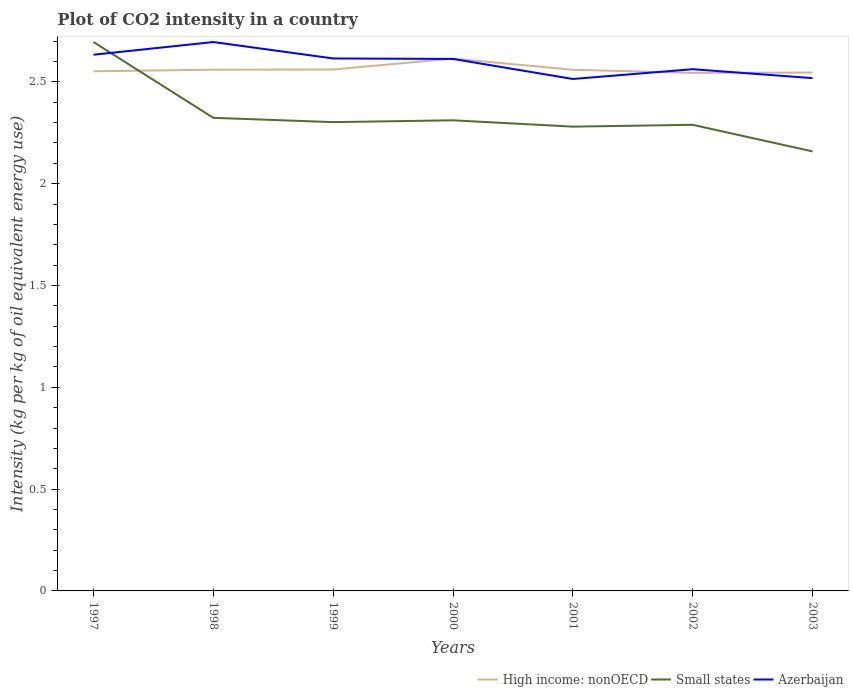Does the line corresponding to High income: nonOECD intersect with the line corresponding to Small states?
Make the answer very short. Yes. Is the number of lines equal to the number of legend labels?
Provide a succinct answer. Yes. Across all years, what is the maximum CO2 intensity in in Azerbaijan?
Ensure brevity in your answer.  2.51. What is the total CO2 intensity in in High income: nonOECD in the graph?
Your answer should be very brief. -0.05. What is the difference between the highest and the second highest CO2 intensity in in Azerbaijan?
Provide a short and direct response. 0.18. What is the difference between the highest and the lowest CO2 intensity in in Small states?
Provide a succinct answer. 1. How many lines are there?
Make the answer very short. 3. How many years are there in the graph?
Your answer should be very brief. 7. What is the difference between two consecutive major ticks on the Y-axis?
Offer a very short reply. 0.5. Are the values on the major ticks of Y-axis written in scientific E-notation?
Provide a succinct answer. No. Does the graph contain any zero values?
Provide a succinct answer. No. Does the graph contain grids?
Offer a terse response. No. What is the title of the graph?
Your answer should be compact. Plot of CO2 intensity in a country. Does "Ecuador" appear as one of the legend labels in the graph?
Your answer should be very brief. No. What is the label or title of the X-axis?
Give a very brief answer. Years. What is the label or title of the Y-axis?
Your answer should be compact. Intensity (kg per kg of oil equivalent energy use). What is the Intensity (kg per kg of oil equivalent energy use) in High income: nonOECD in 1997?
Keep it short and to the point. 2.55. What is the Intensity (kg per kg of oil equivalent energy use) in Small states in 1997?
Offer a very short reply. 2.7. What is the Intensity (kg per kg of oil equivalent energy use) in Azerbaijan in 1997?
Provide a short and direct response. 2.63. What is the Intensity (kg per kg of oil equivalent energy use) of High income: nonOECD in 1998?
Offer a very short reply. 2.56. What is the Intensity (kg per kg of oil equivalent energy use) of Small states in 1998?
Your answer should be compact. 2.32. What is the Intensity (kg per kg of oil equivalent energy use) in Azerbaijan in 1998?
Offer a terse response. 2.7. What is the Intensity (kg per kg of oil equivalent energy use) of High income: nonOECD in 1999?
Provide a succinct answer. 2.56. What is the Intensity (kg per kg of oil equivalent energy use) in Small states in 1999?
Provide a short and direct response. 2.3. What is the Intensity (kg per kg of oil equivalent energy use) in Azerbaijan in 1999?
Offer a terse response. 2.61. What is the Intensity (kg per kg of oil equivalent energy use) in High income: nonOECD in 2000?
Ensure brevity in your answer.  2.61. What is the Intensity (kg per kg of oil equivalent energy use) of Small states in 2000?
Give a very brief answer. 2.31. What is the Intensity (kg per kg of oil equivalent energy use) of Azerbaijan in 2000?
Your answer should be very brief. 2.61. What is the Intensity (kg per kg of oil equivalent energy use) in High income: nonOECD in 2001?
Your response must be concise. 2.56. What is the Intensity (kg per kg of oil equivalent energy use) in Small states in 2001?
Provide a succinct answer. 2.28. What is the Intensity (kg per kg of oil equivalent energy use) of Azerbaijan in 2001?
Offer a terse response. 2.51. What is the Intensity (kg per kg of oil equivalent energy use) of High income: nonOECD in 2002?
Your response must be concise. 2.54. What is the Intensity (kg per kg of oil equivalent energy use) of Small states in 2002?
Give a very brief answer. 2.29. What is the Intensity (kg per kg of oil equivalent energy use) of Azerbaijan in 2002?
Make the answer very short. 2.56. What is the Intensity (kg per kg of oil equivalent energy use) in High income: nonOECD in 2003?
Provide a short and direct response. 2.55. What is the Intensity (kg per kg of oil equivalent energy use) of Small states in 2003?
Make the answer very short. 2.16. What is the Intensity (kg per kg of oil equivalent energy use) of Azerbaijan in 2003?
Provide a succinct answer. 2.52. Across all years, what is the maximum Intensity (kg per kg of oil equivalent energy use) in High income: nonOECD?
Ensure brevity in your answer.  2.61. Across all years, what is the maximum Intensity (kg per kg of oil equivalent energy use) of Small states?
Your answer should be compact. 2.7. Across all years, what is the maximum Intensity (kg per kg of oil equivalent energy use) in Azerbaijan?
Ensure brevity in your answer.  2.7. Across all years, what is the minimum Intensity (kg per kg of oil equivalent energy use) in High income: nonOECD?
Make the answer very short. 2.54. Across all years, what is the minimum Intensity (kg per kg of oil equivalent energy use) of Small states?
Make the answer very short. 2.16. Across all years, what is the minimum Intensity (kg per kg of oil equivalent energy use) of Azerbaijan?
Provide a short and direct response. 2.51. What is the total Intensity (kg per kg of oil equivalent energy use) in High income: nonOECD in the graph?
Your response must be concise. 17.93. What is the total Intensity (kg per kg of oil equivalent energy use) of Small states in the graph?
Provide a succinct answer. 16.36. What is the total Intensity (kg per kg of oil equivalent energy use) of Azerbaijan in the graph?
Your answer should be very brief. 18.15. What is the difference between the Intensity (kg per kg of oil equivalent energy use) in High income: nonOECD in 1997 and that in 1998?
Your answer should be compact. -0.01. What is the difference between the Intensity (kg per kg of oil equivalent energy use) in Small states in 1997 and that in 1998?
Make the answer very short. 0.37. What is the difference between the Intensity (kg per kg of oil equivalent energy use) in Azerbaijan in 1997 and that in 1998?
Offer a terse response. -0.06. What is the difference between the Intensity (kg per kg of oil equivalent energy use) of High income: nonOECD in 1997 and that in 1999?
Ensure brevity in your answer.  -0.01. What is the difference between the Intensity (kg per kg of oil equivalent energy use) in Small states in 1997 and that in 1999?
Keep it short and to the point. 0.39. What is the difference between the Intensity (kg per kg of oil equivalent energy use) of Azerbaijan in 1997 and that in 1999?
Provide a short and direct response. 0.02. What is the difference between the Intensity (kg per kg of oil equivalent energy use) of High income: nonOECD in 1997 and that in 2000?
Give a very brief answer. -0.06. What is the difference between the Intensity (kg per kg of oil equivalent energy use) of Small states in 1997 and that in 2000?
Offer a terse response. 0.38. What is the difference between the Intensity (kg per kg of oil equivalent energy use) in Azerbaijan in 1997 and that in 2000?
Provide a short and direct response. 0.02. What is the difference between the Intensity (kg per kg of oil equivalent energy use) in High income: nonOECD in 1997 and that in 2001?
Your answer should be very brief. -0.01. What is the difference between the Intensity (kg per kg of oil equivalent energy use) of Small states in 1997 and that in 2001?
Give a very brief answer. 0.42. What is the difference between the Intensity (kg per kg of oil equivalent energy use) in Azerbaijan in 1997 and that in 2001?
Provide a succinct answer. 0.12. What is the difference between the Intensity (kg per kg of oil equivalent energy use) in High income: nonOECD in 1997 and that in 2002?
Provide a short and direct response. 0.01. What is the difference between the Intensity (kg per kg of oil equivalent energy use) of Small states in 1997 and that in 2002?
Your answer should be compact. 0.41. What is the difference between the Intensity (kg per kg of oil equivalent energy use) of Azerbaijan in 1997 and that in 2002?
Provide a short and direct response. 0.07. What is the difference between the Intensity (kg per kg of oil equivalent energy use) in High income: nonOECD in 1997 and that in 2003?
Provide a succinct answer. 0.01. What is the difference between the Intensity (kg per kg of oil equivalent energy use) in Small states in 1997 and that in 2003?
Provide a short and direct response. 0.54. What is the difference between the Intensity (kg per kg of oil equivalent energy use) of Azerbaijan in 1997 and that in 2003?
Your response must be concise. 0.12. What is the difference between the Intensity (kg per kg of oil equivalent energy use) of High income: nonOECD in 1998 and that in 1999?
Ensure brevity in your answer.  -0. What is the difference between the Intensity (kg per kg of oil equivalent energy use) of Small states in 1998 and that in 1999?
Keep it short and to the point. 0.02. What is the difference between the Intensity (kg per kg of oil equivalent energy use) of Azerbaijan in 1998 and that in 1999?
Provide a succinct answer. 0.08. What is the difference between the Intensity (kg per kg of oil equivalent energy use) in High income: nonOECD in 1998 and that in 2000?
Your response must be concise. -0.05. What is the difference between the Intensity (kg per kg of oil equivalent energy use) in Small states in 1998 and that in 2000?
Your answer should be compact. 0.01. What is the difference between the Intensity (kg per kg of oil equivalent energy use) in Azerbaijan in 1998 and that in 2000?
Provide a short and direct response. 0.08. What is the difference between the Intensity (kg per kg of oil equivalent energy use) of Small states in 1998 and that in 2001?
Your answer should be very brief. 0.04. What is the difference between the Intensity (kg per kg of oil equivalent energy use) in Azerbaijan in 1998 and that in 2001?
Offer a terse response. 0.18. What is the difference between the Intensity (kg per kg of oil equivalent energy use) of High income: nonOECD in 1998 and that in 2002?
Offer a very short reply. 0.02. What is the difference between the Intensity (kg per kg of oil equivalent energy use) of Small states in 1998 and that in 2002?
Your answer should be compact. 0.03. What is the difference between the Intensity (kg per kg of oil equivalent energy use) in Azerbaijan in 1998 and that in 2002?
Provide a succinct answer. 0.13. What is the difference between the Intensity (kg per kg of oil equivalent energy use) in High income: nonOECD in 1998 and that in 2003?
Your answer should be very brief. 0.01. What is the difference between the Intensity (kg per kg of oil equivalent energy use) in Small states in 1998 and that in 2003?
Offer a very short reply. 0.16. What is the difference between the Intensity (kg per kg of oil equivalent energy use) in Azerbaijan in 1998 and that in 2003?
Offer a very short reply. 0.18. What is the difference between the Intensity (kg per kg of oil equivalent energy use) of High income: nonOECD in 1999 and that in 2000?
Make the answer very short. -0.05. What is the difference between the Intensity (kg per kg of oil equivalent energy use) of Small states in 1999 and that in 2000?
Provide a short and direct response. -0.01. What is the difference between the Intensity (kg per kg of oil equivalent energy use) in Azerbaijan in 1999 and that in 2000?
Give a very brief answer. 0. What is the difference between the Intensity (kg per kg of oil equivalent energy use) of High income: nonOECD in 1999 and that in 2001?
Give a very brief answer. 0. What is the difference between the Intensity (kg per kg of oil equivalent energy use) in Small states in 1999 and that in 2001?
Provide a succinct answer. 0.02. What is the difference between the Intensity (kg per kg of oil equivalent energy use) of Azerbaijan in 1999 and that in 2001?
Your answer should be very brief. 0.1. What is the difference between the Intensity (kg per kg of oil equivalent energy use) in High income: nonOECD in 1999 and that in 2002?
Your answer should be compact. 0.02. What is the difference between the Intensity (kg per kg of oil equivalent energy use) of Small states in 1999 and that in 2002?
Your answer should be compact. 0.01. What is the difference between the Intensity (kg per kg of oil equivalent energy use) in Azerbaijan in 1999 and that in 2002?
Provide a succinct answer. 0.05. What is the difference between the Intensity (kg per kg of oil equivalent energy use) in High income: nonOECD in 1999 and that in 2003?
Your answer should be compact. 0.02. What is the difference between the Intensity (kg per kg of oil equivalent energy use) in Small states in 1999 and that in 2003?
Your answer should be compact. 0.14. What is the difference between the Intensity (kg per kg of oil equivalent energy use) of Azerbaijan in 1999 and that in 2003?
Offer a very short reply. 0.1. What is the difference between the Intensity (kg per kg of oil equivalent energy use) in High income: nonOECD in 2000 and that in 2001?
Ensure brevity in your answer.  0.05. What is the difference between the Intensity (kg per kg of oil equivalent energy use) in Small states in 2000 and that in 2001?
Offer a very short reply. 0.03. What is the difference between the Intensity (kg per kg of oil equivalent energy use) in Azerbaijan in 2000 and that in 2001?
Your answer should be compact. 0.1. What is the difference between the Intensity (kg per kg of oil equivalent energy use) in High income: nonOECD in 2000 and that in 2002?
Ensure brevity in your answer.  0.07. What is the difference between the Intensity (kg per kg of oil equivalent energy use) of Small states in 2000 and that in 2002?
Provide a short and direct response. 0.02. What is the difference between the Intensity (kg per kg of oil equivalent energy use) of Azerbaijan in 2000 and that in 2002?
Provide a short and direct response. 0.05. What is the difference between the Intensity (kg per kg of oil equivalent energy use) of High income: nonOECD in 2000 and that in 2003?
Provide a short and direct response. 0.07. What is the difference between the Intensity (kg per kg of oil equivalent energy use) in Small states in 2000 and that in 2003?
Ensure brevity in your answer.  0.15. What is the difference between the Intensity (kg per kg of oil equivalent energy use) of Azerbaijan in 2000 and that in 2003?
Your response must be concise. 0.09. What is the difference between the Intensity (kg per kg of oil equivalent energy use) in High income: nonOECD in 2001 and that in 2002?
Ensure brevity in your answer.  0.02. What is the difference between the Intensity (kg per kg of oil equivalent energy use) in Small states in 2001 and that in 2002?
Offer a very short reply. -0.01. What is the difference between the Intensity (kg per kg of oil equivalent energy use) in Azerbaijan in 2001 and that in 2002?
Provide a succinct answer. -0.05. What is the difference between the Intensity (kg per kg of oil equivalent energy use) of High income: nonOECD in 2001 and that in 2003?
Provide a succinct answer. 0.01. What is the difference between the Intensity (kg per kg of oil equivalent energy use) in Small states in 2001 and that in 2003?
Provide a short and direct response. 0.12. What is the difference between the Intensity (kg per kg of oil equivalent energy use) in Azerbaijan in 2001 and that in 2003?
Provide a short and direct response. -0. What is the difference between the Intensity (kg per kg of oil equivalent energy use) of High income: nonOECD in 2002 and that in 2003?
Provide a succinct answer. -0. What is the difference between the Intensity (kg per kg of oil equivalent energy use) in Small states in 2002 and that in 2003?
Offer a terse response. 0.13. What is the difference between the Intensity (kg per kg of oil equivalent energy use) of Azerbaijan in 2002 and that in 2003?
Offer a terse response. 0.04. What is the difference between the Intensity (kg per kg of oil equivalent energy use) in High income: nonOECD in 1997 and the Intensity (kg per kg of oil equivalent energy use) in Small states in 1998?
Provide a short and direct response. 0.23. What is the difference between the Intensity (kg per kg of oil equivalent energy use) of High income: nonOECD in 1997 and the Intensity (kg per kg of oil equivalent energy use) of Azerbaijan in 1998?
Offer a terse response. -0.14. What is the difference between the Intensity (kg per kg of oil equivalent energy use) of Small states in 1997 and the Intensity (kg per kg of oil equivalent energy use) of Azerbaijan in 1998?
Your response must be concise. -0. What is the difference between the Intensity (kg per kg of oil equivalent energy use) of High income: nonOECD in 1997 and the Intensity (kg per kg of oil equivalent energy use) of Small states in 1999?
Offer a terse response. 0.25. What is the difference between the Intensity (kg per kg of oil equivalent energy use) of High income: nonOECD in 1997 and the Intensity (kg per kg of oil equivalent energy use) of Azerbaijan in 1999?
Provide a succinct answer. -0.06. What is the difference between the Intensity (kg per kg of oil equivalent energy use) in Small states in 1997 and the Intensity (kg per kg of oil equivalent energy use) in Azerbaijan in 1999?
Provide a succinct answer. 0.08. What is the difference between the Intensity (kg per kg of oil equivalent energy use) of High income: nonOECD in 1997 and the Intensity (kg per kg of oil equivalent energy use) of Small states in 2000?
Offer a terse response. 0.24. What is the difference between the Intensity (kg per kg of oil equivalent energy use) of High income: nonOECD in 1997 and the Intensity (kg per kg of oil equivalent energy use) of Azerbaijan in 2000?
Provide a succinct answer. -0.06. What is the difference between the Intensity (kg per kg of oil equivalent energy use) in Small states in 1997 and the Intensity (kg per kg of oil equivalent energy use) in Azerbaijan in 2000?
Make the answer very short. 0.08. What is the difference between the Intensity (kg per kg of oil equivalent energy use) of High income: nonOECD in 1997 and the Intensity (kg per kg of oil equivalent energy use) of Small states in 2001?
Offer a very short reply. 0.27. What is the difference between the Intensity (kg per kg of oil equivalent energy use) of High income: nonOECD in 1997 and the Intensity (kg per kg of oil equivalent energy use) of Azerbaijan in 2001?
Your answer should be compact. 0.04. What is the difference between the Intensity (kg per kg of oil equivalent energy use) of Small states in 1997 and the Intensity (kg per kg of oil equivalent energy use) of Azerbaijan in 2001?
Give a very brief answer. 0.18. What is the difference between the Intensity (kg per kg of oil equivalent energy use) in High income: nonOECD in 1997 and the Intensity (kg per kg of oil equivalent energy use) in Small states in 2002?
Give a very brief answer. 0.26. What is the difference between the Intensity (kg per kg of oil equivalent energy use) of High income: nonOECD in 1997 and the Intensity (kg per kg of oil equivalent energy use) of Azerbaijan in 2002?
Your answer should be compact. -0.01. What is the difference between the Intensity (kg per kg of oil equivalent energy use) in Small states in 1997 and the Intensity (kg per kg of oil equivalent energy use) in Azerbaijan in 2002?
Provide a succinct answer. 0.13. What is the difference between the Intensity (kg per kg of oil equivalent energy use) of High income: nonOECD in 1997 and the Intensity (kg per kg of oil equivalent energy use) of Small states in 2003?
Offer a very short reply. 0.39. What is the difference between the Intensity (kg per kg of oil equivalent energy use) in High income: nonOECD in 1997 and the Intensity (kg per kg of oil equivalent energy use) in Azerbaijan in 2003?
Offer a terse response. 0.03. What is the difference between the Intensity (kg per kg of oil equivalent energy use) in Small states in 1997 and the Intensity (kg per kg of oil equivalent energy use) in Azerbaijan in 2003?
Keep it short and to the point. 0.18. What is the difference between the Intensity (kg per kg of oil equivalent energy use) of High income: nonOECD in 1998 and the Intensity (kg per kg of oil equivalent energy use) of Small states in 1999?
Make the answer very short. 0.26. What is the difference between the Intensity (kg per kg of oil equivalent energy use) in High income: nonOECD in 1998 and the Intensity (kg per kg of oil equivalent energy use) in Azerbaijan in 1999?
Provide a short and direct response. -0.06. What is the difference between the Intensity (kg per kg of oil equivalent energy use) in Small states in 1998 and the Intensity (kg per kg of oil equivalent energy use) in Azerbaijan in 1999?
Ensure brevity in your answer.  -0.29. What is the difference between the Intensity (kg per kg of oil equivalent energy use) in High income: nonOECD in 1998 and the Intensity (kg per kg of oil equivalent energy use) in Small states in 2000?
Give a very brief answer. 0.25. What is the difference between the Intensity (kg per kg of oil equivalent energy use) in High income: nonOECD in 1998 and the Intensity (kg per kg of oil equivalent energy use) in Azerbaijan in 2000?
Ensure brevity in your answer.  -0.05. What is the difference between the Intensity (kg per kg of oil equivalent energy use) of Small states in 1998 and the Intensity (kg per kg of oil equivalent energy use) of Azerbaijan in 2000?
Make the answer very short. -0.29. What is the difference between the Intensity (kg per kg of oil equivalent energy use) in High income: nonOECD in 1998 and the Intensity (kg per kg of oil equivalent energy use) in Small states in 2001?
Make the answer very short. 0.28. What is the difference between the Intensity (kg per kg of oil equivalent energy use) of High income: nonOECD in 1998 and the Intensity (kg per kg of oil equivalent energy use) of Azerbaijan in 2001?
Provide a succinct answer. 0.05. What is the difference between the Intensity (kg per kg of oil equivalent energy use) in Small states in 1998 and the Intensity (kg per kg of oil equivalent energy use) in Azerbaijan in 2001?
Make the answer very short. -0.19. What is the difference between the Intensity (kg per kg of oil equivalent energy use) in High income: nonOECD in 1998 and the Intensity (kg per kg of oil equivalent energy use) in Small states in 2002?
Keep it short and to the point. 0.27. What is the difference between the Intensity (kg per kg of oil equivalent energy use) of High income: nonOECD in 1998 and the Intensity (kg per kg of oil equivalent energy use) of Azerbaijan in 2002?
Ensure brevity in your answer.  -0. What is the difference between the Intensity (kg per kg of oil equivalent energy use) of Small states in 1998 and the Intensity (kg per kg of oil equivalent energy use) of Azerbaijan in 2002?
Offer a terse response. -0.24. What is the difference between the Intensity (kg per kg of oil equivalent energy use) of High income: nonOECD in 1998 and the Intensity (kg per kg of oil equivalent energy use) of Small states in 2003?
Provide a succinct answer. 0.4. What is the difference between the Intensity (kg per kg of oil equivalent energy use) in High income: nonOECD in 1998 and the Intensity (kg per kg of oil equivalent energy use) in Azerbaijan in 2003?
Make the answer very short. 0.04. What is the difference between the Intensity (kg per kg of oil equivalent energy use) in Small states in 1998 and the Intensity (kg per kg of oil equivalent energy use) in Azerbaijan in 2003?
Provide a succinct answer. -0.19. What is the difference between the Intensity (kg per kg of oil equivalent energy use) in High income: nonOECD in 1999 and the Intensity (kg per kg of oil equivalent energy use) in Small states in 2000?
Keep it short and to the point. 0.25. What is the difference between the Intensity (kg per kg of oil equivalent energy use) of High income: nonOECD in 1999 and the Intensity (kg per kg of oil equivalent energy use) of Azerbaijan in 2000?
Provide a succinct answer. -0.05. What is the difference between the Intensity (kg per kg of oil equivalent energy use) of Small states in 1999 and the Intensity (kg per kg of oil equivalent energy use) of Azerbaijan in 2000?
Your answer should be very brief. -0.31. What is the difference between the Intensity (kg per kg of oil equivalent energy use) of High income: nonOECD in 1999 and the Intensity (kg per kg of oil equivalent energy use) of Small states in 2001?
Give a very brief answer. 0.28. What is the difference between the Intensity (kg per kg of oil equivalent energy use) in High income: nonOECD in 1999 and the Intensity (kg per kg of oil equivalent energy use) in Azerbaijan in 2001?
Your answer should be very brief. 0.05. What is the difference between the Intensity (kg per kg of oil equivalent energy use) of Small states in 1999 and the Intensity (kg per kg of oil equivalent energy use) of Azerbaijan in 2001?
Your response must be concise. -0.21. What is the difference between the Intensity (kg per kg of oil equivalent energy use) in High income: nonOECD in 1999 and the Intensity (kg per kg of oil equivalent energy use) in Small states in 2002?
Your response must be concise. 0.27. What is the difference between the Intensity (kg per kg of oil equivalent energy use) of High income: nonOECD in 1999 and the Intensity (kg per kg of oil equivalent energy use) of Azerbaijan in 2002?
Offer a very short reply. -0. What is the difference between the Intensity (kg per kg of oil equivalent energy use) in Small states in 1999 and the Intensity (kg per kg of oil equivalent energy use) in Azerbaijan in 2002?
Your answer should be very brief. -0.26. What is the difference between the Intensity (kg per kg of oil equivalent energy use) of High income: nonOECD in 1999 and the Intensity (kg per kg of oil equivalent energy use) of Small states in 2003?
Offer a very short reply. 0.4. What is the difference between the Intensity (kg per kg of oil equivalent energy use) in High income: nonOECD in 1999 and the Intensity (kg per kg of oil equivalent energy use) in Azerbaijan in 2003?
Offer a terse response. 0.04. What is the difference between the Intensity (kg per kg of oil equivalent energy use) of Small states in 1999 and the Intensity (kg per kg of oil equivalent energy use) of Azerbaijan in 2003?
Your response must be concise. -0.22. What is the difference between the Intensity (kg per kg of oil equivalent energy use) of High income: nonOECD in 2000 and the Intensity (kg per kg of oil equivalent energy use) of Small states in 2001?
Offer a very short reply. 0.33. What is the difference between the Intensity (kg per kg of oil equivalent energy use) in High income: nonOECD in 2000 and the Intensity (kg per kg of oil equivalent energy use) in Azerbaijan in 2001?
Your answer should be compact. 0.1. What is the difference between the Intensity (kg per kg of oil equivalent energy use) in Small states in 2000 and the Intensity (kg per kg of oil equivalent energy use) in Azerbaijan in 2001?
Your response must be concise. -0.2. What is the difference between the Intensity (kg per kg of oil equivalent energy use) in High income: nonOECD in 2000 and the Intensity (kg per kg of oil equivalent energy use) in Small states in 2002?
Your answer should be very brief. 0.33. What is the difference between the Intensity (kg per kg of oil equivalent energy use) of High income: nonOECD in 2000 and the Intensity (kg per kg of oil equivalent energy use) of Azerbaijan in 2002?
Your answer should be compact. 0.05. What is the difference between the Intensity (kg per kg of oil equivalent energy use) in Small states in 2000 and the Intensity (kg per kg of oil equivalent energy use) in Azerbaijan in 2002?
Give a very brief answer. -0.25. What is the difference between the Intensity (kg per kg of oil equivalent energy use) in High income: nonOECD in 2000 and the Intensity (kg per kg of oil equivalent energy use) in Small states in 2003?
Your response must be concise. 0.46. What is the difference between the Intensity (kg per kg of oil equivalent energy use) in High income: nonOECD in 2000 and the Intensity (kg per kg of oil equivalent energy use) in Azerbaijan in 2003?
Keep it short and to the point. 0.1. What is the difference between the Intensity (kg per kg of oil equivalent energy use) of Small states in 2000 and the Intensity (kg per kg of oil equivalent energy use) of Azerbaijan in 2003?
Offer a terse response. -0.21. What is the difference between the Intensity (kg per kg of oil equivalent energy use) in High income: nonOECD in 2001 and the Intensity (kg per kg of oil equivalent energy use) in Small states in 2002?
Provide a succinct answer. 0.27. What is the difference between the Intensity (kg per kg of oil equivalent energy use) in High income: nonOECD in 2001 and the Intensity (kg per kg of oil equivalent energy use) in Azerbaijan in 2002?
Ensure brevity in your answer.  -0. What is the difference between the Intensity (kg per kg of oil equivalent energy use) of Small states in 2001 and the Intensity (kg per kg of oil equivalent energy use) of Azerbaijan in 2002?
Your answer should be compact. -0.28. What is the difference between the Intensity (kg per kg of oil equivalent energy use) in High income: nonOECD in 2001 and the Intensity (kg per kg of oil equivalent energy use) in Small states in 2003?
Provide a short and direct response. 0.4. What is the difference between the Intensity (kg per kg of oil equivalent energy use) of High income: nonOECD in 2001 and the Intensity (kg per kg of oil equivalent energy use) of Azerbaijan in 2003?
Your answer should be compact. 0.04. What is the difference between the Intensity (kg per kg of oil equivalent energy use) in Small states in 2001 and the Intensity (kg per kg of oil equivalent energy use) in Azerbaijan in 2003?
Your answer should be very brief. -0.24. What is the difference between the Intensity (kg per kg of oil equivalent energy use) of High income: nonOECD in 2002 and the Intensity (kg per kg of oil equivalent energy use) of Small states in 2003?
Provide a succinct answer. 0.39. What is the difference between the Intensity (kg per kg of oil equivalent energy use) in High income: nonOECD in 2002 and the Intensity (kg per kg of oil equivalent energy use) in Azerbaijan in 2003?
Make the answer very short. 0.03. What is the difference between the Intensity (kg per kg of oil equivalent energy use) in Small states in 2002 and the Intensity (kg per kg of oil equivalent energy use) in Azerbaijan in 2003?
Offer a very short reply. -0.23. What is the average Intensity (kg per kg of oil equivalent energy use) in High income: nonOECD per year?
Make the answer very short. 2.56. What is the average Intensity (kg per kg of oil equivalent energy use) in Small states per year?
Provide a succinct answer. 2.34. What is the average Intensity (kg per kg of oil equivalent energy use) in Azerbaijan per year?
Keep it short and to the point. 2.59. In the year 1997, what is the difference between the Intensity (kg per kg of oil equivalent energy use) of High income: nonOECD and Intensity (kg per kg of oil equivalent energy use) of Small states?
Ensure brevity in your answer.  -0.14. In the year 1997, what is the difference between the Intensity (kg per kg of oil equivalent energy use) of High income: nonOECD and Intensity (kg per kg of oil equivalent energy use) of Azerbaijan?
Your answer should be very brief. -0.08. In the year 1997, what is the difference between the Intensity (kg per kg of oil equivalent energy use) in Small states and Intensity (kg per kg of oil equivalent energy use) in Azerbaijan?
Provide a short and direct response. 0.06. In the year 1998, what is the difference between the Intensity (kg per kg of oil equivalent energy use) of High income: nonOECD and Intensity (kg per kg of oil equivalent energy use) of Small states?
Ensure brevity in your answer.  0.24. In the year 1998, what is the difference between the Intensity (kg per kg of oil equivalent energy use) in High income: nonOECD and Intensity (kg per kg of oil equivalent energy use) in Azerbaijan?
Offer a very short reply. -0.14. In the year 1998, what is the difference between the Intensity (kg per kg of oil equivalent energy use) in Small states and Intensity (kg per kg of oil equivalent energy use) in Azerbaijan?
Keep it short and to the point. -0.37. In the year 1999, what is the difference between the Intensity (kg per kg of oil equivalent energy use) of High income: nonOECD and Intensity (kg per kg of oil equivalent energy use) of Small states?
Provide a succinct answer. 0.26. In the year 1999, what is the difference between the Intensity (kg per kg of oil equivalent energy use) of High income: nonOECD and Intensity (kg per kg of oil equivalent energy use) of Azerbaijan?
Ensure brevity in your answer.  -0.05. In the year 1999, what is the difference between the Intensity (kg per kg of oil equivalent energy use) in Small states and Intensity (kg per kg of oil equivalent energy use) in Azerbaijan?
Your answer should be very brief. -0.31. In the year 2000, what is the difference between the Intensity (kg per kg of oil equivalent energy use) of High income: nonOECD and Intensity (kg per kg of oil equivalent energy use) of Small states?
Your response must be concise. 0.3. In the year 2000, what is the difference between the Intensity (kg per kg of oil equivalent energy use) of High income: nonOECD and Intensity (kg per kg of oil equivalent energy use) of Azerbaijan?
Your response must be concise. 0. In the year 2000, what is the difference between the Intensity (kg per kg of oil equivalent energy use) of Small states and Intensity (kg per kg of oil equivalent energy use) of Azerbaijan?
Your answer should be compact. -0.3. In the year 2001, what is the difference between the Intensity (kg per kg of oil equivalent energy use) of High income: nonOECD and Intensity (kg per kg of oil equivalent energy use) of Small states?
Keep it short and to the point. 0.28. In the year 2001, what is the difference between the Intensity (kg per kg of oil equivalent energy use) in High income: nonOECD and Intensity (kg per kg of oil equivalent energy use) in Azerbaijan?
Your response must be concise. 0.05. In the year 2001, what is the difference between the Intensity (kg per kg of oil equivalent energy use) of Small states and Intensity (kg per kg of oil equivalent energy use) of Azerbaijan?
Offer a very short reply. -0.23. In the year 2002, what is the difference between the Intensity (kg per kg of oil equivalent energy use) of High income: nonOECD and Intensity (kg per kg of oil equivalent energy use) of Small states?
Offer a terse response. 0.26. In the year 2002, what is the difference between the Intensity (kg per kg of oil equivalent energy use) in High income: nonOECD and Intensity (kg per kg of oil equivalent energy use) in Azerbaijan?
Offer a terse response. -0.02. In the year 2002, what is the difference between the Intensity (kg per kg of oil equivalent energy use) of Small states and Intensity (kg per kg of oil equivalent energy use) of Azerbaijan?
Provide a short and direct response. -0.27. In the year 2003, what is the difference between the Intensity (kg per kg of oil equivalent energy use) of High income: nonOECD and Intensity (kg per kg of oil equivalent energy use) of Small states?
Provide a short and direct response. 0.39. In the year 2003, what is the difference between the Intensity (kg per kg of oil equivalent energy use) in High income: nonOECD and Intensity (kg per kg of oil equivalent energy use) in Azerbaijan?
Make the answer very short. 0.03. In the year 2003, what is the difference between the Intensity (kg per kg of oil equivalent energy use) of Small states and Intensity (kg per kg of oil equivalent energy use) of Azerbaijan?
Your response must be concise. -0.36. What is the ratio of the Intensity (kg per kg of oil equivalent energy use) in High income: nonOECD in 1997 to that in 1998?
Your answer should be very brief. 1. What is the ratio of the Intensity (kg per kg of oil equivalent energy use) of Small states in 1997 to that in 1998?
Provide a short and direct response. 1.16. What is the ratio of the Intensity (kg per kg of oil equivalent energy use) in Azerbaijan in 1997 to that in 1998?
Make the answer very short. 0.98. What is the ratio of the Intensity (kg per kg of oil equivalent energy use) of High income: nonOECD in 1997 to that in 1999?
Ensure brevity in your answer.  1. What is the ratio of the Intensity (kg per kg of oil equivalent energy use) in Small states in 1997 to that in 1999?
Your answer should be very brief. 1.17. What is the ratio of the Intensity (kg per kg of oil equivalent energy use) in High income: nonOECD in 1997 to that in 2000?
Ensure brevity in your answer.  0.98. What is the ratio of the Intensity (kg per kg of oil equivalent energy use) in Small states in 1997 to that in 2000?
Provide a short and direct response. 1.17. What is the ratio of the Intensity (kg per kg of oil equivalent energy use) of Azerbaijan in 1997 to that in 2000?
Provide a short and direct response. 1.01. What is the ratio of the Intensity (kg per kg of oil equivalent energy use) in Small states in 1997 to that in 2001?
Your response must be concise. 1.18. What is the ratio of the Intensity (kg per kg of oil equivalent energy use) in Azerbaijan in 1997 to that in 2001?
Offer a terse response. 1.05. What is the ratio of the Intensity (kg per kg of oil equivalent energy use) of Small states in 1997 to that in 2002?
Make the answer very short. 1.18. What is the ratio of the Intensity (kg per kg of oil equivalent energy use) in Azerbaijan in 1997 to that in 2002?
Offer a terse response. 1.03. What is the ratio of the Intensity (kg per kg of oil equivalent energy use) of Small states in 1997 to that in 2003?
Provide a succinct answer. 1.25. What is the ratio of the Intensity (kg per kg of oil equivalent energy use) of Azerbaijan in 1997 to that in 2003?
Your answer should be very brief. 1.05. What is the ratio of the Intensity (kg per kg of oil equivalent energy use) of Small states in 1998 to that in 1999?
Offer a terse response. 1.01. What is the ratio of the Intensity (kg per kg of oil equivalent energy use) in Azerbaijan in 1998 to that in 1999?
Your answer should be very brief. 1.03. What is the ratio of the Intensity (kg per kg of oil equivalent energy use) of High income: nonOECD in 1998 to that in 2000?
Offer a terse response. 0.98. What is the ratio of the Intensity (kg per kg of oil equivalent energy use) of Azerbaijan in 1998 to that in 2000?
Your response must be concise. 1.03. What is the ratio of the Intensity (kg per kg of oil equivalent energy use) in Azerbaijan in 1998 to that in 2001?
Your answer should be compact. 1.07. What is the ratio of the Intensity (kg per kg of oil equivalent energy use) in High income: nonOECD in 1998 to that in 2002?
Make the answer very short. 1.01. What is the ratio of the Intensity (kg per kg of oil equivalent energy use) in Small states in 1998 to that in 2002?
Ensure brevity in your answer.  1.01. What is the ratio of the Intensity (kg per kg of oil equivalent energy use) of Azerbaijan in 1998 to that in 2002?
Offer a terse response. 1.05. What is the ratio of the Intensity (kg per kg of oil equivalent energy use) of Small states in 1998 to that in 2003?
Your response must be concise. 1.08. What is the ratio of the Intensity (kg per kg of oil equivalent energy use) in Azerbaijan in 1998 to that in 2003?
Make the answer very short. 1.07. What is the ratio of the Intensity (kg per kg of oil equivalent energy use) of High income: nonOECD in 1999 to that in 2000?
Your response must be concise. 0.98. What is the ratio of the Intensity (kg per kg of oil equivalent energy use) in Small states in 1999 to that in 2000?
Your answer should be compact. 1. What is the ratio of the Intensity (kg per kg of oil equivalent energy use) of Azerbaijan in 1999 to that in 2000?
Offer a terse response. 1. What is the ratio of the Intensity (kg per kg of oil equivalent energy use) of High income: nonOECD in 1999 to that in 2001?
Provide a short and direct response. 1. What is the ratio of the Intensity (kg per kg of oil equivalent energy use) of Small states in 1999 to that in 2001?
Your answer should be compact. 1.01. What is the ratio of the Intensity (kg per kg of oil equivalent energy use) in Azerbaijan in 1999 to that in 2001?
Offer a terse response. 1.04. What is the ratio of the Intensity (kg per kg of oil equivalent energy use) in High income: nonOECD in 1999 to that in 2002?
Give a very brief answer. 1.01. What is the ratio of the Intensity (kg per kg of oil equivalent energy use) of Small states in 1999 to that in 2002?
Offer a very short reply. 1.01. What is the ratio of the Intensity (kg per kg of oil equivalent energy use) in Azerbaijan in 1999 to that in 2002?
Provide a short and direct response. 1.02. What is the ratio of the Intensity (kg per kg of oil equivalent energy use) in High income: nonOECD in 1999 to that in 2003?
Give a very brief answer. 1.01. What is the ratio of the Intensity (kg per kg of oil equivalent energy use) in Small states in 1999 to that in 2003?
Keep it short and to the point. 1.07. What is the ratio of the Intensity (kg per kg of oil equivalent energy use) in Azerbaijan in 1999 to that in 2003?
Your response must be concise. 1.04. What is the ratio of the Intensity (kg per kg of oil equivalent energy use) in High income: nonOECD in 2000 to that in 2001?
Make the answer very short. 1.02. What is the ratio of the Intensity (kg per kg of oil equivalent energy use) of Small states in 2000 to that in 2001?
Provide a short and direct response. 1.01. What is the ratio of the Intensity (kg per kg of oil equivalent energy use) of Azerbaijan in 2000 to that in 2001?
Your response must be concise. 1.04. What is the ratio of the Intensity (kg per kg of oil equivalent energy use) in High income: nonOECD in 2000 to that in 2002?
Give a very brief answer. 1.03. What is the ratio of the Intensity (kg per kg of oil equivalent energy use) of Small states in 2000 to that in 2002?
Keep it short and to the point. 1.01. What is the ratio of the Intensity (kg per kg of oil equivalent energy use) of Azerbaijan in 2000 to that in 2002?
Offer a very short reply. 1.02. What is the ratio of the Intensity (kg per kg of oil equivalent energy use) in High income: nonOECD in 2000 to that in 2003?
Provide a short and direct response. 1.03. What is the ratio of the Intensity (kg per kg of oil equivalent energy use) in Small states in 2000 to that in 2003?
Make the answer very short. 1.07. What is the ratio of the Intensity (kg per kg of oil equivalent energy use) of Azerbaijan in 2000 to that in 2003?
Give a very brief answer. 1.04. What is the ratio of the Intensity (kg per kg of oil equivalent energy use) of Azerbaijan in 2001 to that in 2002?
Your answer should be very brief. 0.98. What is the ratio of the Intensity (kg per kg of oil equivalent energy use) of High income: nonOECD in 2001 to that in 2003?
Keep it short and to the point. 1.01. What is the ratio of the Intensity (kg per kg of oil equivalent energy use) of Small states in 2001 to that in 2003?
Provide a succinct answer. 1.06. What is the ratio of the Intensity (kg per kg of oil equivalent energy use) of Small states in 2002 to that in 2003?
Provide a short and direct response. 1.06. What is the ratio of the Intensity (kg per kg of oil equivalent energy use) of Azerbaijan in 2002 to that in 2003?
Provide a succinct answer. 1.02. What is the difference between the highest and the second highest Intensity (kg per kg of oil equivalent energy use) in High income: nonOECD?
Offer a terse response. 0.05. What is the difference between the highest and the second highest Intensity (kg per kg of oil equivalent energy use) in Small states?
Give a very brief answer. 0.37. What is the difference between the highest and the second highest Intensity (kg per kg of oil equivalent energy use) of Azerbaijan?
Your answer should be very brief. 0.06. What is the difference between the highest and the lowest Intensity (kg per kg of oil equivalent energy use) in High income: nonOECD?
Offer a terse response. 0.07. What is the difference between the highest and the lowest Intensity (kg per kg of oil equivalent energy use) in Small states?
Ensure brevity in your answer.  0.54. What is the difference between the highest and the lowest Intensity (kg per kg of oil equivalent energy use) of Azerbaijan?
Ensure brevity in your answer.  0.18. 